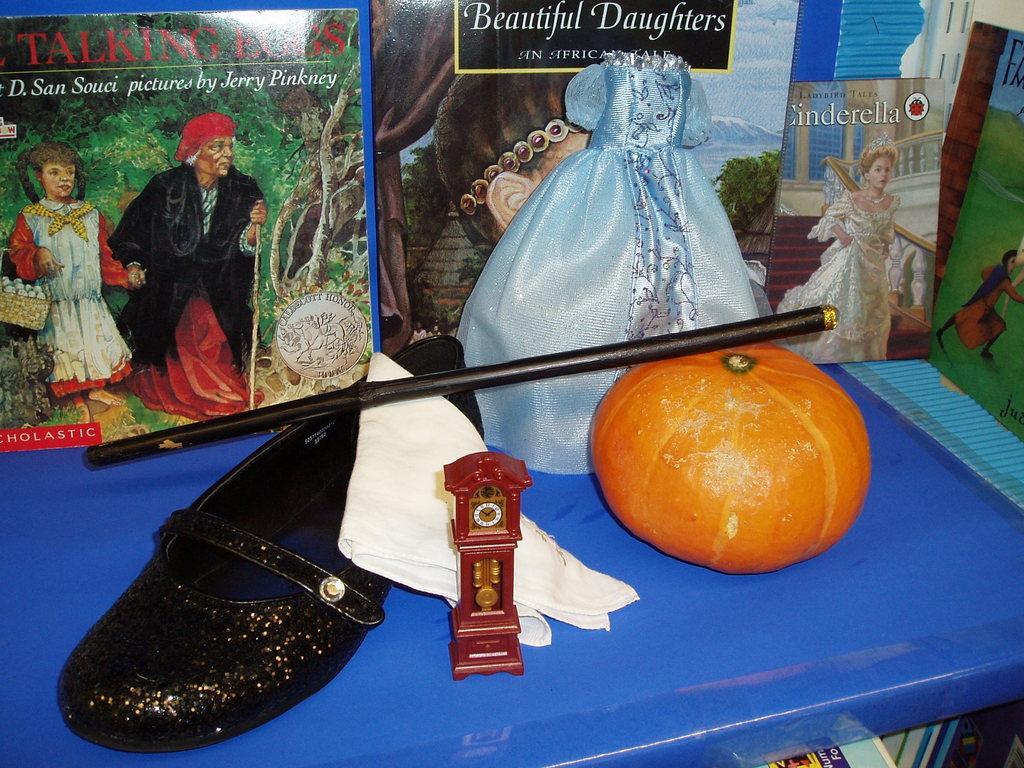Describe this image in one or two sentences. In this picture we can see a shoe, a toy, an orange, a cloth and a stick in the front, there are some photographs in the background, there is some text and pictures of persons on these photographs. 